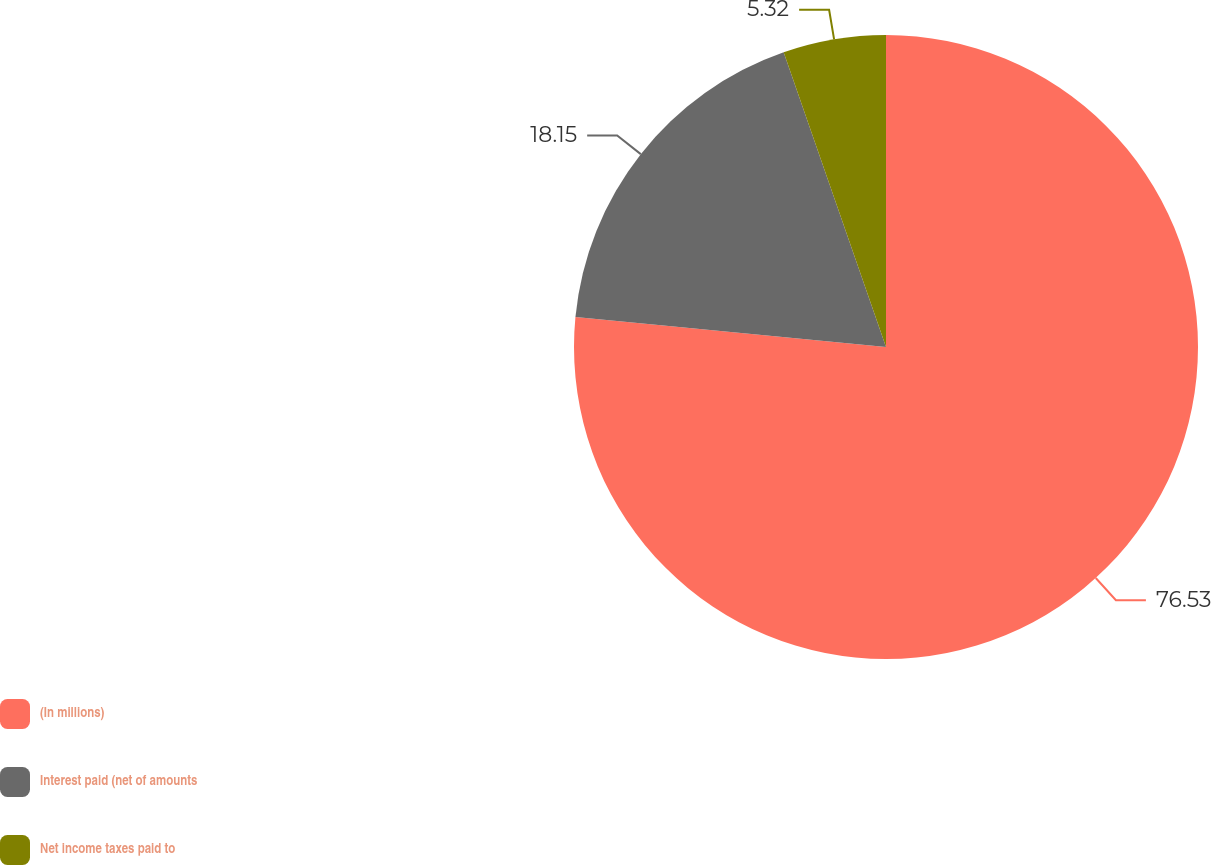<chart> <loc_0><loc_0><loc_500><loc_500><pie_chart><fcel>(In millions)<fcel>Interest paid (net of amounts<fcel>Net income taxes paid to<nl><fcel>76.54%<fcel>18.15%<fcel>5.32%<nl></chart> 